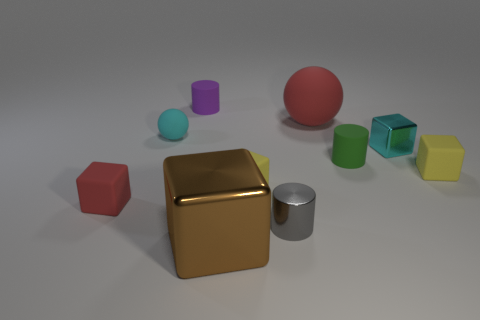Is the tiny red thing that is in front of the tiny green matte object made of the same material as the cylinder in front of the red rubber cube?
Offer a terse response. No. There is a metal block that is to the right of the brown metal block; how many tiny gray shiny things are behind it?
Make the answer very short. 0. There is a red rubber thing on the right side of the brown thing; is it the same shape as the yellow thing left of the green matte object?
Make the answer very short. No. There is a metal object that is both left of the red sphere and behind the large brown thing; what size is it?
Provide a succinct answer. Small. The small object that is the same shape as the big rubber thing is what color?
Your answer should be compact. Cyan. What color is the rubber sphere that is left of the small gray object right of the large brown thing?
Give a very brief answer. Cyan. What is the shape of the purple thing?
Provide a short and direct response. Cylinder. The thing that is to the left of the brown cube and on the right side of the small matte ball has what shape?
Provide a short and direct response. Cylinder. There is a large sphere that is the same material as the purple object; what color is it?
Provide a short and direct response. Red. There is a red rubber object that is to the right of the shiny cube on the left side of the red object that is to the right of the large shiny cube; what is its shape?
Provide a succinct answer. Sphere. 